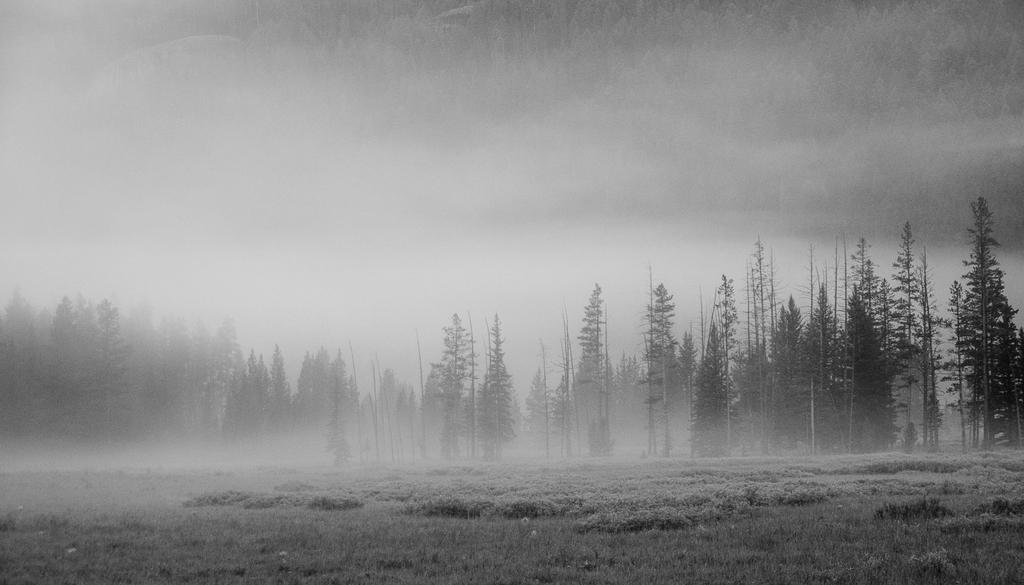What is the color scheme of the image? The image is black and white. What type of vegetation can be seen in the image? There are many trees and plants in the image. What is the ground covered with in the image? There is grass in the image. What atmospheric condition is present in the image? There is fog in the image. What part of the natural environment is visible in the image? The sky is visible in the image. What type of space vessel can be seen in the image? There is no space vessel present in the image; it features a black and white landscape with trees, plants, grass, fog, and a visible sky. What mark does the tree on the left have on its trunk? There is no specific mark mentioned on the tree trunk in the image, as it is a general description of the trees and plants in the scene. 